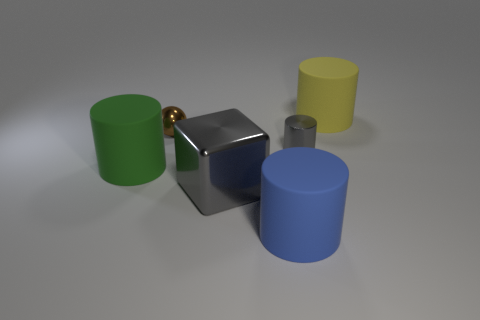What size is the thing that is the same color as the big shiny block?
Provide a succinct answer. Small. How many big metal objects have the same color as the big cube?
Make the answer very short. 0. The metallic block that is the same size as the yellow thing is what color?
Offer a very short reply. Gray. Is the big thing to the right of the blue matte object made of the same material as the gray cylinder?
Your answer should be compact. No. What is the size of the object that is on the right side of the large gray metallic block and in front of the large green rubber object?
Your answer should be very brief. Large. How big is the cylinder that is behind the brown metal object?
Offer a very short reply. Large. There is a big metallic thing that is the same color as the small cylinder; what is its shape?
Your answer should be compact. Cube. What shape is the tiny metal thing behind the gray metallic thing that is behind the object that is left of the shiny ball?
Provide a succinct answer. Sphere. How many other things are the same shape as the brown metallic object?
Provide a succinct answer. 0. What number of rubber things are either gray things or big gray things?
Offer a very short reply. 0. 